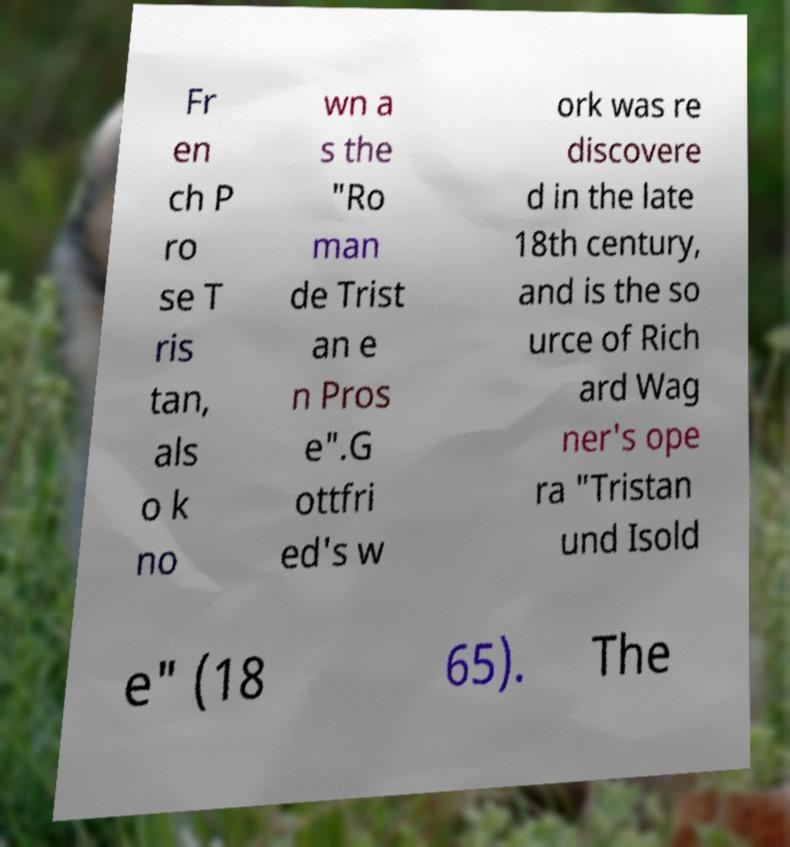Please identify and transcribe the text found in this image. Fr en ch P ro se T ris tan, als o k no wn a s the "Ro man de Trist an e n Pros e".G ottfri ed's w ork was re discovere d in the late 18th century, and is the so urce of Rich ard Wag ner's ope ra "Tristan und Isold e" (18 65). The 